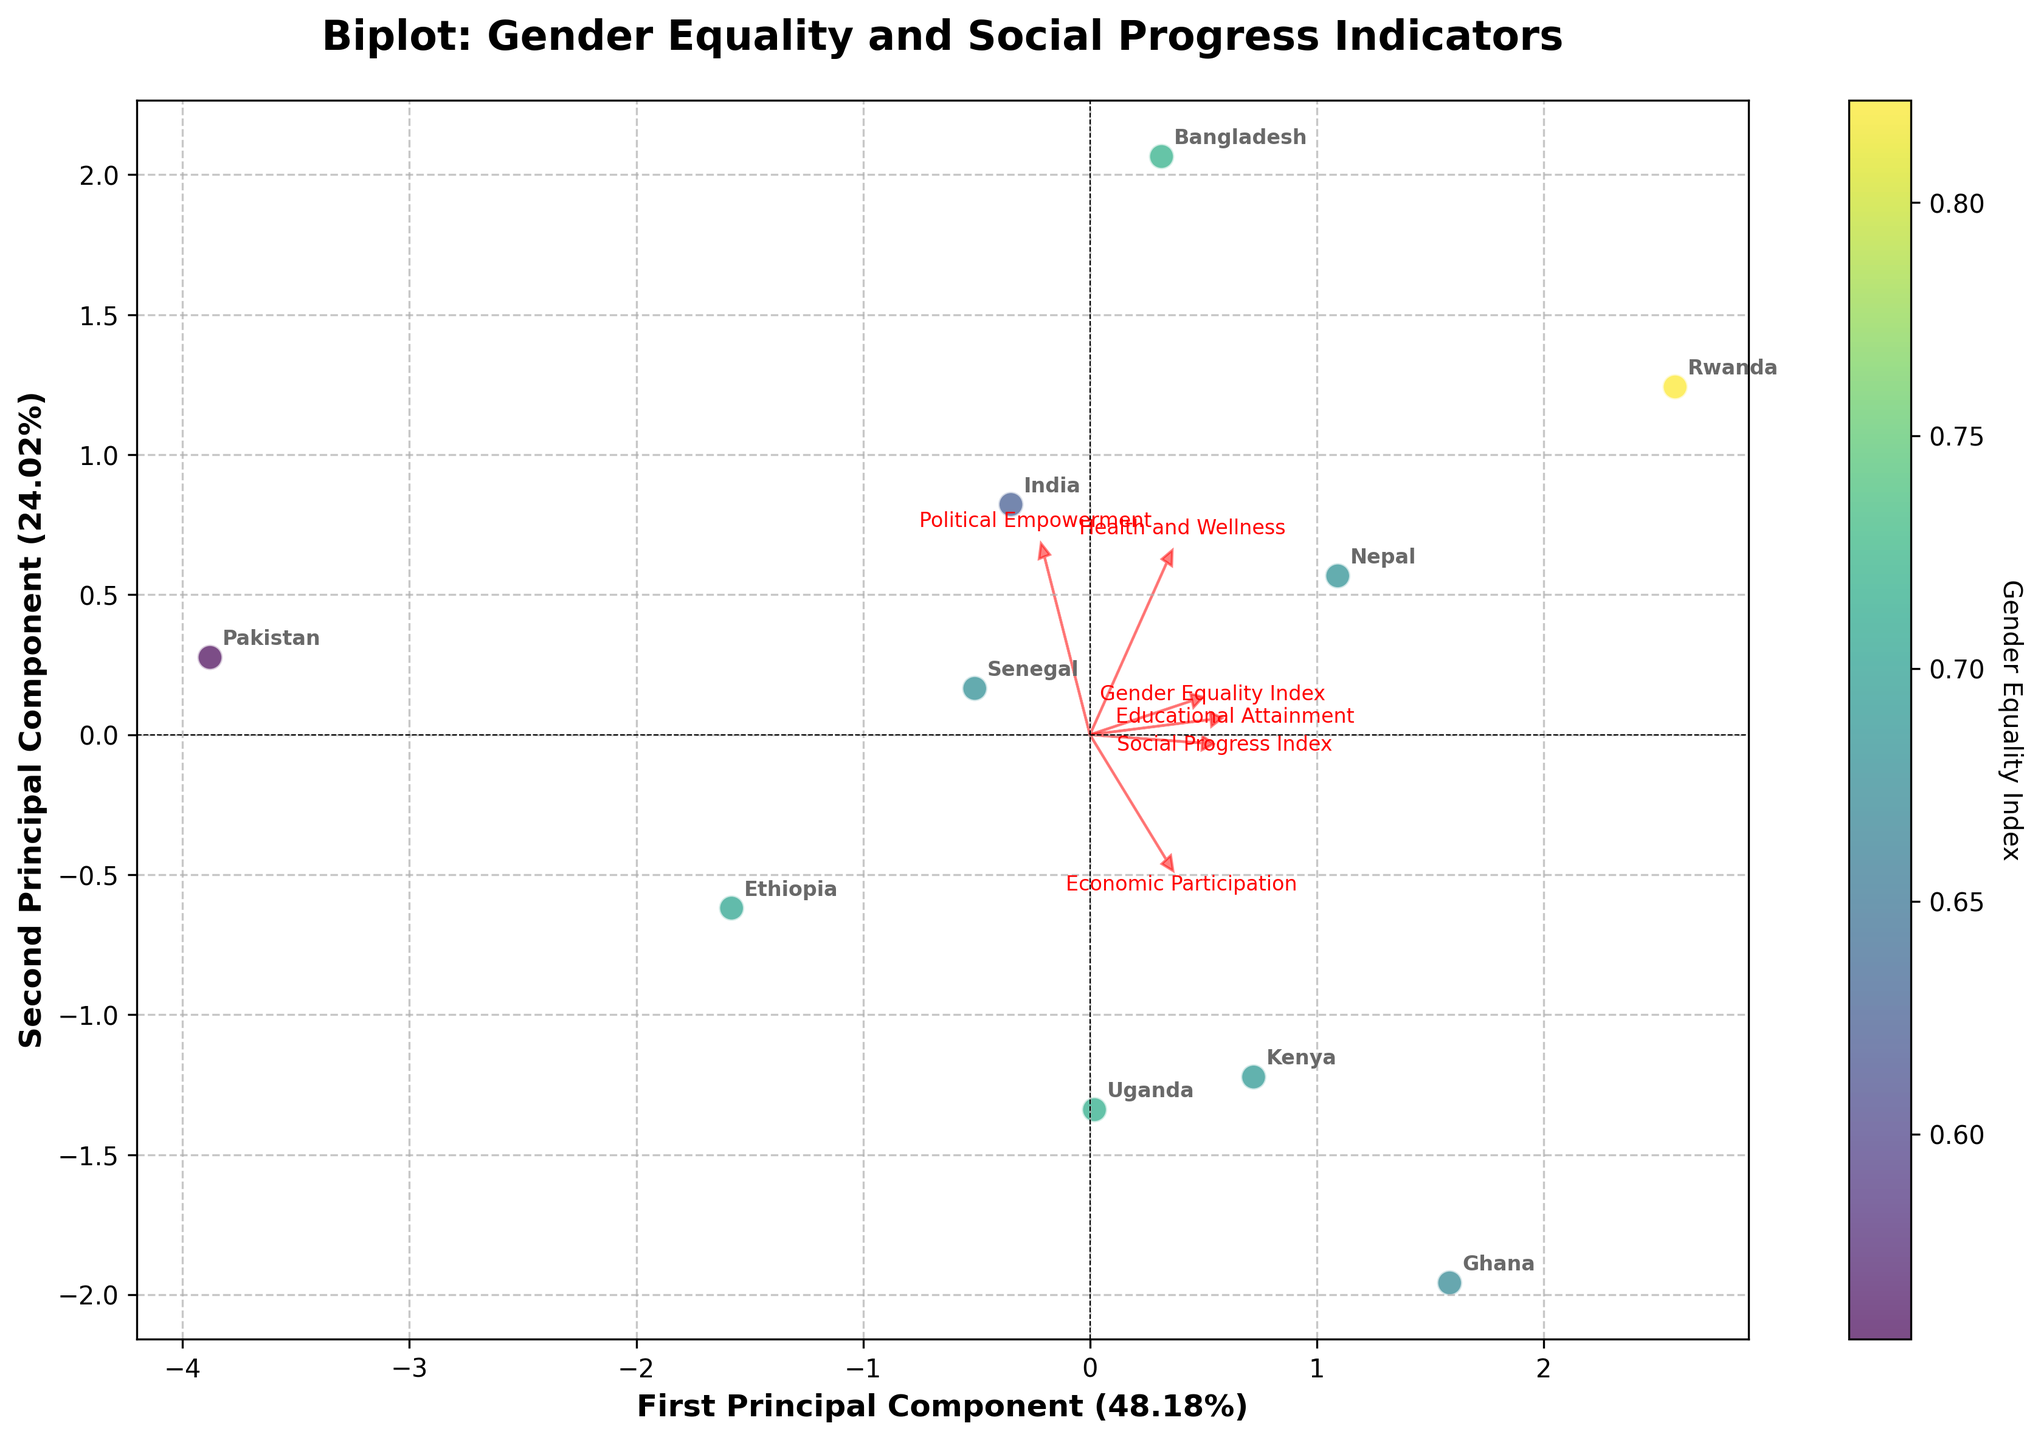What is the title of the plot? The title is written at the top of the plot, indicating the main topic or purpose of the visualization.
Answer: Biplot: Gender Equality and Social Progress Indicators How many principal components are displayed in the plot? The x-axis and y-axis labels indicate the number of principal components displayed by mentioning "First Principal Component" and "Second Principal Component".
Answer: Two Which country has the highest Gender Equality Index based on the color scale? The color scale on the side shows the range of Gender Equality Index values, and the brightest/most intense color corresponds to the highest value. Observing the plot, we see that Rwanda is associated with the highest value.
Answer: Rwanda Which feature vector has the largest magnitude in the direction of the first principal component? The lengths of the arrows pointing in the direction of the first principal component (x-axis) indicate the magnitude of the feature vectors. The feature with the arrow extending farthest along the first principal component is "Educational Attainment".
Answer: Educational Attainment Which two countries are closest to each other in the plot and what might that suggest? By observing the distances between the country labels on the plot, we can identify that Kenya and Ethiopia are plotted very close to each other, suggesting similar characteristics in terms of the principal components.
Answer: Kenya and Ethiopia What proportion of variance is explained by the first principal component? This information is provided on the x-axis label as a percentage in parentheses after "First Principal Component".
Answer: Approximately 37.28% If we consider both principal components, what is the total variance explained by the plot? We sum the variance explained by the first and second principal components. According to the axis labels, these are approximately 37.28% and 23.47%, respectively. So, total variance explained is 37.28% + 23.47%.
Answer: Approximately 60.75% Which social progress indicator seems least correlated with gender equality indices based on the vector directions and lengths? Feature vectors pointing in similar directions indicate higher correlations, while those pointing in different directions or having shorter lengths indicate weaker correlations. "Health and Wellness" shows a relatively shorter arrow and different alignment compared to the Gender Equality Index vector.
Answer: Health and Wellness What does the arrow direction of "Political Empowerment" suggest about its relationship with the two principal components? The arrow for "Political Empowerment" points primarily in the negative y-direction (second principal component), suggesting it has a stronger influence on the second principal component rather than the first. This implies that variations in political empowerment are more captured by the second principal component.
Answer: Stronger influence on the second principal component 